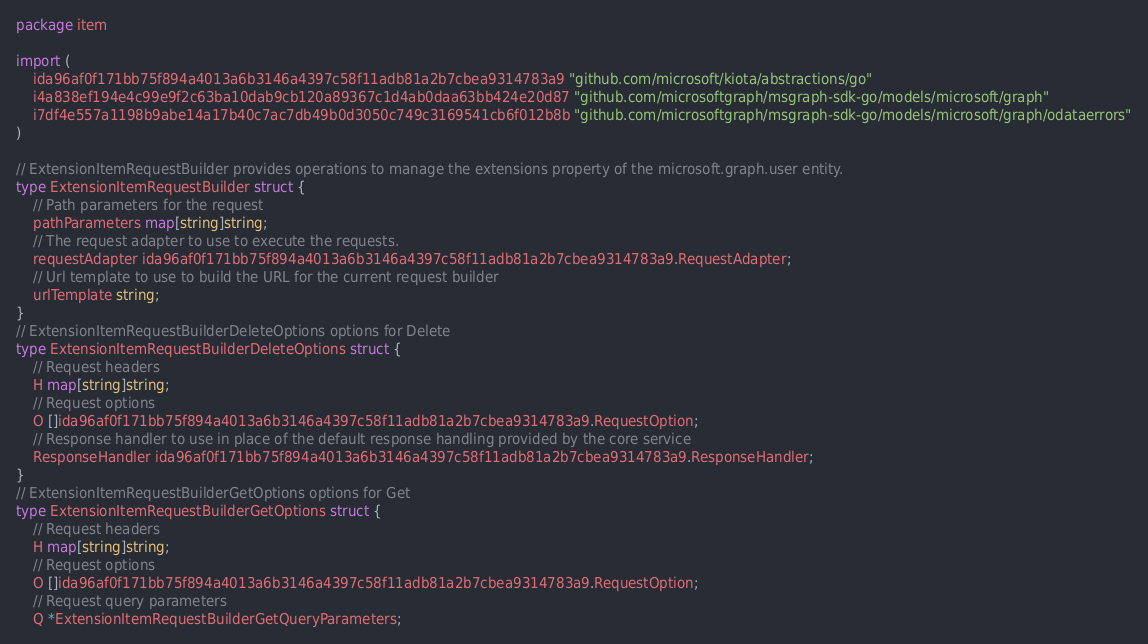<code> <loc_0><loc_0><loc_500><loc_500><_Go_>package item

import (
    ida96af0f171bb75f894a4013a6b3146a4397c58f11adb81a2b7cbea9314783a9 "github.com/microsoft/kiota/abstractions/go"
    i4a838ef194e4c99e9f2c63ba10dab9cb120a89367c1d4ab0daa63bb424e20d87 "github.com/microsoftgraph/msgraph-sdk-go/models/microsoft/graph"
    i7df4e557a1198b9abe14a17b40c7ac7db49b0d3050c749c3169541cb6f012b8b "github.com/microsoftgraph/msgraph-sdk-go/models/microsoft/graph/odataerrors"
)

// ExtensionItemRequestBuilder provides operations to manage the extensions property of the microsoft.graph.user entity.
type ExtensionItemRequestBuilder struct {
    // Path parameters for the request
    pathParameters map[string]string;
    // The request adapter to use to execute the requests.
    requestAdapter ida96af0f171bb75f894a4013a6b3146a4397c58f11adb81a2b7cbea9314783a9.RequestAdapter;
    // Url template to use to build the URL for the current request builder
    urlTemplate string;
}
// ExtensionItemRequestBuilderDeleteOptions options for Delete
type ExtensionItemRequestBuilderDeleteOptions struct {
    // Request headers
    H map[string]string;
    // Request options
    O []ida96af0f171bb75f894a4013a6b3146a4397c58f11adb81a2b7cbea9314783a9.RequestOption;
    // Response handler to use in place of the default response handling provided by the core service
    ResponseHandler ida96af0f171bb75f894a4013a6b3146a4397c58f11adb81a2b7cbea9314783a9.ResponseHandler;
}
// ExtensionItemRequestBuilderGetOptions options for Get
type ExtensionItemRequestBuilderGetOptions struct {
    // Request headers
    H map[string]string;
    // Request options
    O []ida96af0f171bb75f894a4013a6b3146a4397c58f11adb81a2b7cbea9314783a9.RequestOption;
    // Request query parameters
    Q *ExtensionItemRequestBuilderGetQueryParameters;</code> 